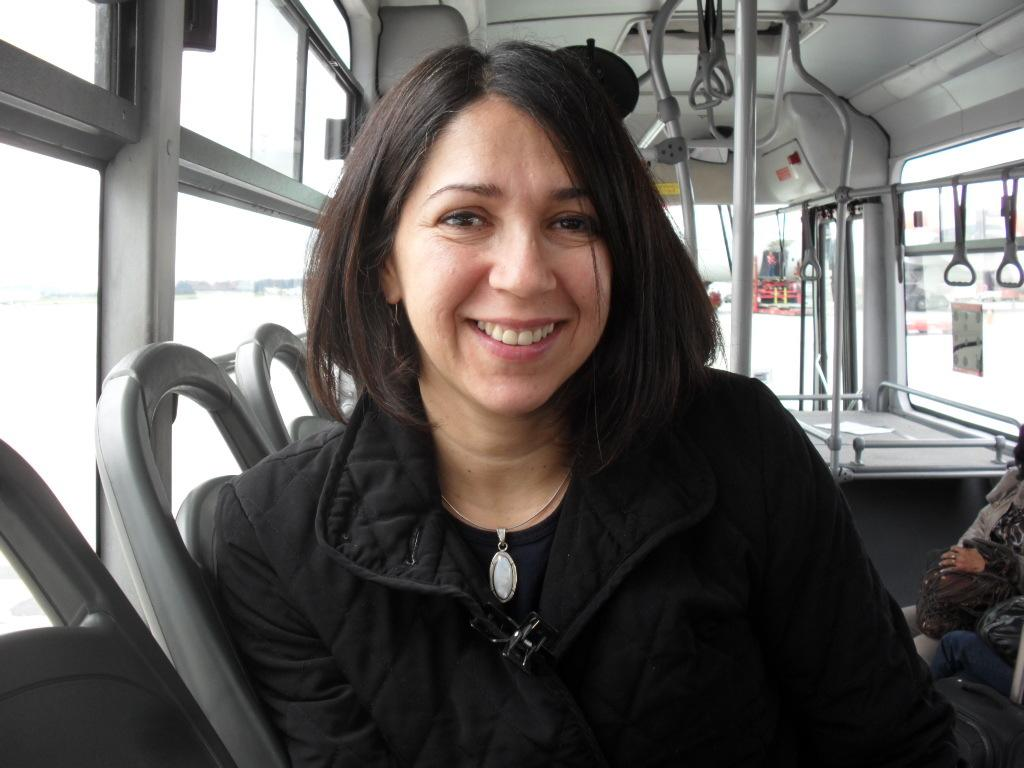Who is present in the image? There is a woman in the image. What is the woman wearing? The woman is wearing a black jacket. Where is the woman sitting? The woman is sitting in a bus. What can be seen on the left side of the bus? There are windows on the left side of the bus. What part of the bus is visible in the image? There is a roof visible in the image. What degree does the woman hold, as seen in the image? There is no indication in the image of the woman's degree or educational background. 